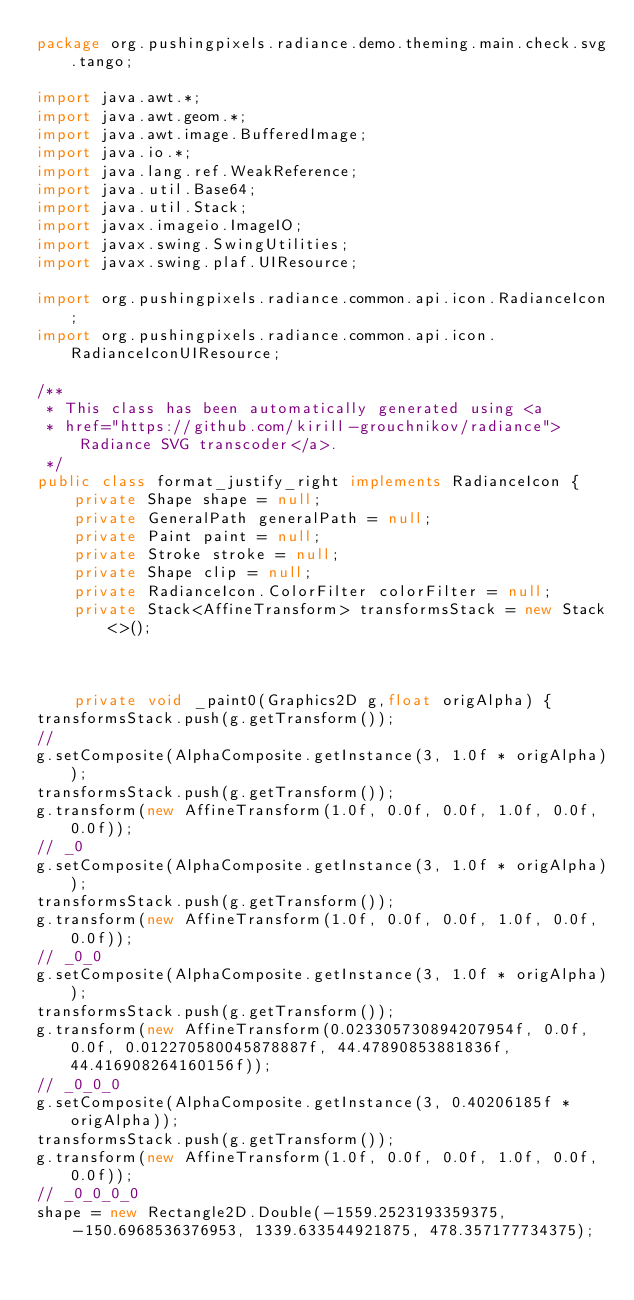Convert code to text. <code><loc_0><loc_0><loc_500><loc_500><_Java_>package org.pushingpixels.radiance.demo.theming.main.check.svg.tango;

import java.awt.*;
import java.awt.geom.*;
import java.awt.image.BufferedImage;
import java.io.*;
import java.lang.ref.WeakReference;
import java.util.Base64;
import java.util.Stack;
import javax.imageio.ImageIO;
import javax.swing.SwingUtilities;
import javax.swing.plaf.UIResource;

import org.pushingpixels.radiance.common.api.icon.RadianceIcon;
import org.pushingpixels.radiance.common.api.icon.RadianceIconUIResource;

/**
 * This class has been automatically generated using <a
 * href="https://github.com/kirill-grouchnikov/radiance">Radiance SVG transcoder</a>.
 */
public class format_justify_right implements RadianceIcon {
    private Shape shape = null;
    private GeneralPath generalPath = null;
    private Paint paint = null;
    private Stroke stroke = null;
    private Shape clip = null;
    private RadianceIcon.ColorFilter colorFilter = null;
    private Stack<AffineTransform> transformsStack = new Stack<>();

    

	private void _paint0(Graphics2D g,float origAlpha) {
transformsStack.push(g.getTransform());
// 
g.setComposite(AlphaComposite.getInstance(3, 1.0f * origAlpha));
transformsStack.push(g.getTransform());
g.transform(new AffineTransform(1.0f, 0.0f, 0.0f, 1.0f, 0.0f, 0.0f));
// _0
g.setComposite(AlphaComposite.getInstance(3, 1.0f * origAlpha));
transformsStack.push(g.getTransform());
g.transform(new AffineTransform(1.0f, 0.0f, 0.0f, 1.0f, 0.0f, 0.0f));
// _0_0
g.setComposite(AlphaComposite.getInstance(3, 1.0f * origAlpha));
transformsStack.push(g.getTransform());
g.transform(new AffineTransform(0.023305730894207954f, 0.0f, 0.0f, 0.012270580045878887f, 44.47890853881836f, 44.416908264160156f));
// _0_0_0
g.setComposite(AlphaComposite.getInstance(3, 0.40206185f * origAlpha));
transformsStack.push(g.getTransform());
g.transform(new AffineTransform(1.0f, 0.0f, 0.0f, 1.0f, 0.0f, 0.0f));
// _0_0_0_0
shape = new Rectangle2D.Double(-1559.2523193359375, -150.6968536376953, 1339.633544921875, 478.357177734375);</code> 